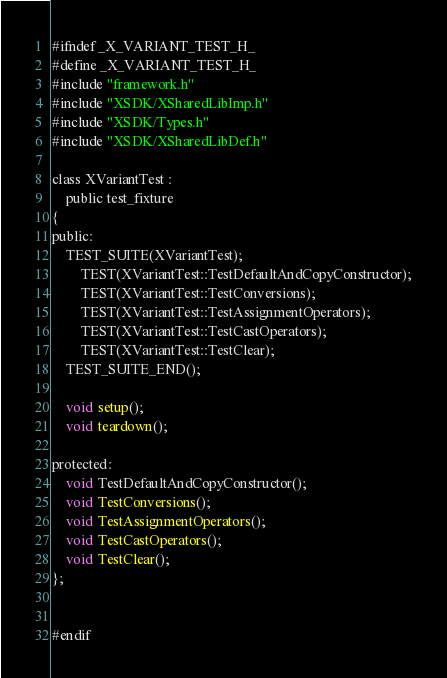<code> <loc_0><loc_0><loc_500><loc_500><_C_>
#ifndef _X_VARIANT_TEST_H_
#define _X_VARIANT_TEST_H_
#include "framework.h"
#include "XSDK/XSharedLibImp.h"
#include "XSDK/Types.h"
#include "XSDK/XSharedLibDef.h"

class XVariantTest :
    public test_fixture
{
public:
    TEST_SUITE(XVariantTest);
        TEST(XVariantTest::TestDefaultAndCopyConstructor);
        TEST(XVariantTest::TestConversions);
        TEST(XVariantTest::TestAssignmentOperators);
        TEST(XVariantTest::TestCastOperators);
        TEST(XVariantTest::TestClear);
    TEST_SUITE_END();

    void setup();
    void teardown();

protected:
    void TestDefaultAndCopyConstructor();
    void TestConversions();
    void TestAssignmentOperators();
    void TestCastOperators();
    void TestClear();
};


#endif
</code> 